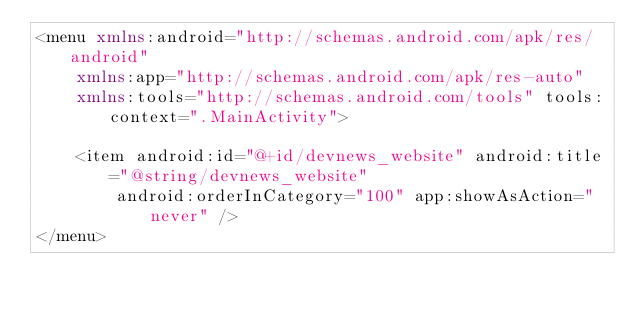<code> <loc_0><loc_0><loc_500><loc_500><_XML_><menu xmlns:android="http://schemas.android.com/apk/res/android"
    xmlns:app="http://schemas.android.com/apk/res-auto"
    xmlns:tools="http://schemas.android.com/tools" tools:context=".MainActivity">

    <item android:id="@+id/devnews_website" android:title="@string/devnews_website"
        android:orderInCategory="100" app:showAsAction="never" />
</menu>
</code> 